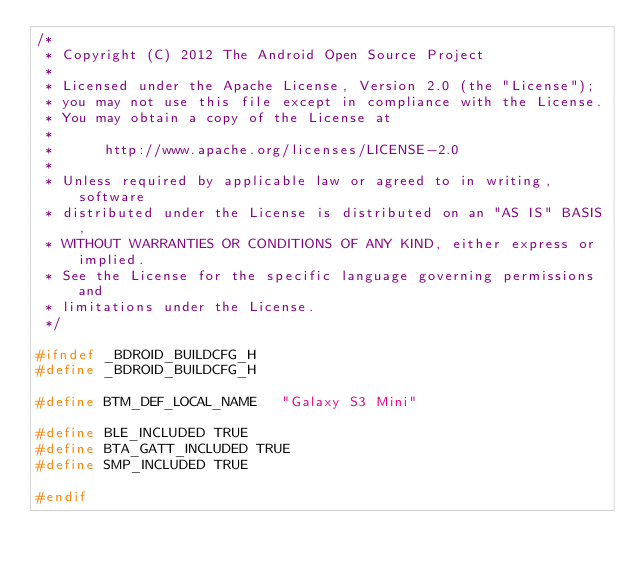Convert code to text. <code><loc_0><loc_0><loc_500><loc_500><_C_>/*
 * Copyright (C) 2012 The Android Open Source Project
 *
 * Licensed under the Apache License, Version 2.0 (the "License");
 * you may not use this file except in compliance with the License.
 * You may obtain a copy of the License at
 *
 *      http://www.apache.org/licenses/LICENSE-2.0
 *
 * Unless required by applicable law or agreed to in writing, software
 * distributed under the License is distributed on an "AS IS" BASIS,
 * WITHOUT WARRANTIES OR CONDITIONS OF ANY KIND, either express or implied.
 * See the License for the specific language governing permissions and
 * limitations under the License.
 */

#ifndef _BDROID_BUILDCFG_H
#define _BDROID_BUILDCFG_H

#define BTM_DEF_LOCAL_NAME   "Galaxy S3 Mini"

#define BLE_INCLUDED TRUE
#define BTA_GATT_INCLUDED TRUE
#define SMP_INCLUDED TRUE

#endif
</code> 